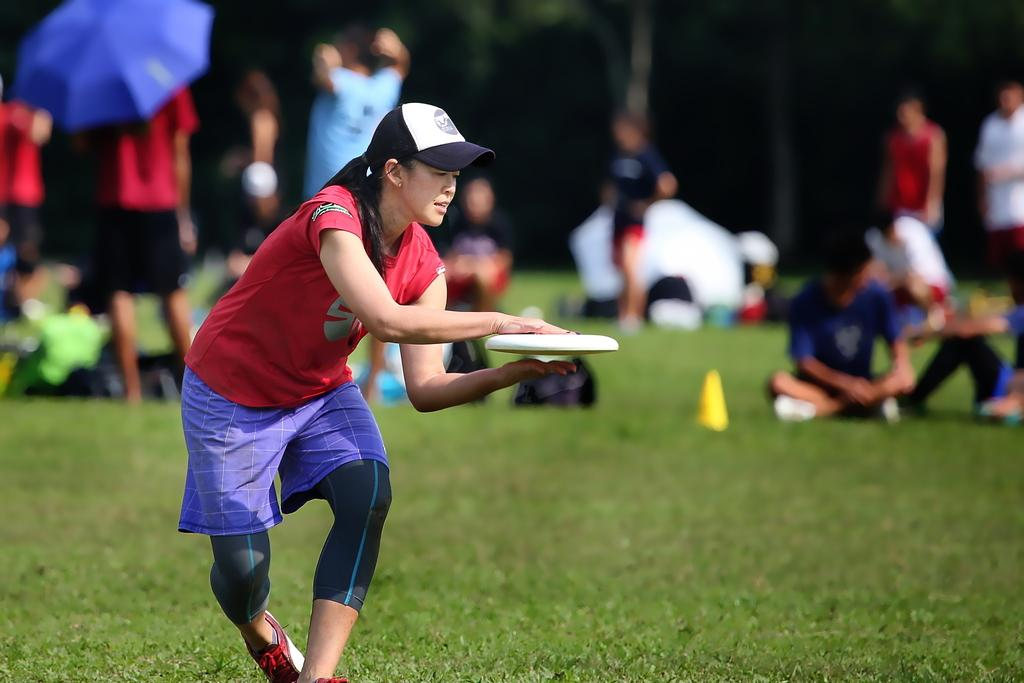Who is the main subject in the image? There is a woman in the image. What is the woman doing with her hands? The woman's hands are near a disc. Can you describe the background of the image? The background of the image is blurry, and there are people, an umbrella, and grass visible. What type of shoe is the squirrel wearing in the image? There is no squirrel present in the image, and therefore no shoes or squirrels can be observed. 